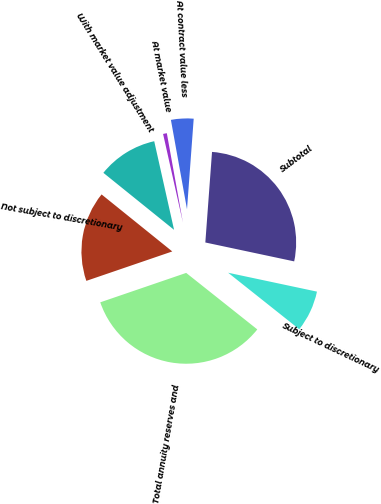Convert chart to OTSL. <chart><loc_0><loc_0><loc_500><loc_500><pie_chart><fcel>Not subject to discretionary<fcel>With market value adjustment<fcel>At market value<fcel>At contract value less<fcel>Subtotal<fcel>Subject to discretionary<fcel>Total annuity reserves and<nl><fcel>16.05%<fcel>10.69%<fcel>0.67%<fcel>4.01%<fcel>27.16%<fcel>7.35%<fcel>34.06%<nl></chart> 